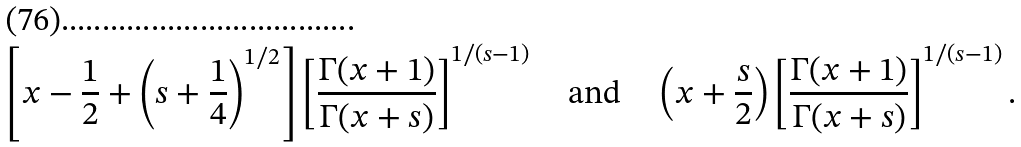Convert formula to latex. <formula><loc_0><loc_0><loc_500><loc_500>\left [ x - \frac { 1 } { 2 } + \left ( s + \frac { 1 } { 4 } \right ) ^ { 1 / 2 } \right ] \left [ \frac { \Gamma ( x + 1 ) } { \Gamma ( x + s ) } \right ] ^ { 1 / ( s - 1 ) } \quad \text {and} \quad \left ( x + \frac { s } 2 \right ) \left [ \frac { \Gamma ( x + 1 ) } { \Gamma ( x + s ) } \right ] ^ { 1 / ( s - 1 ) } .</formula> 